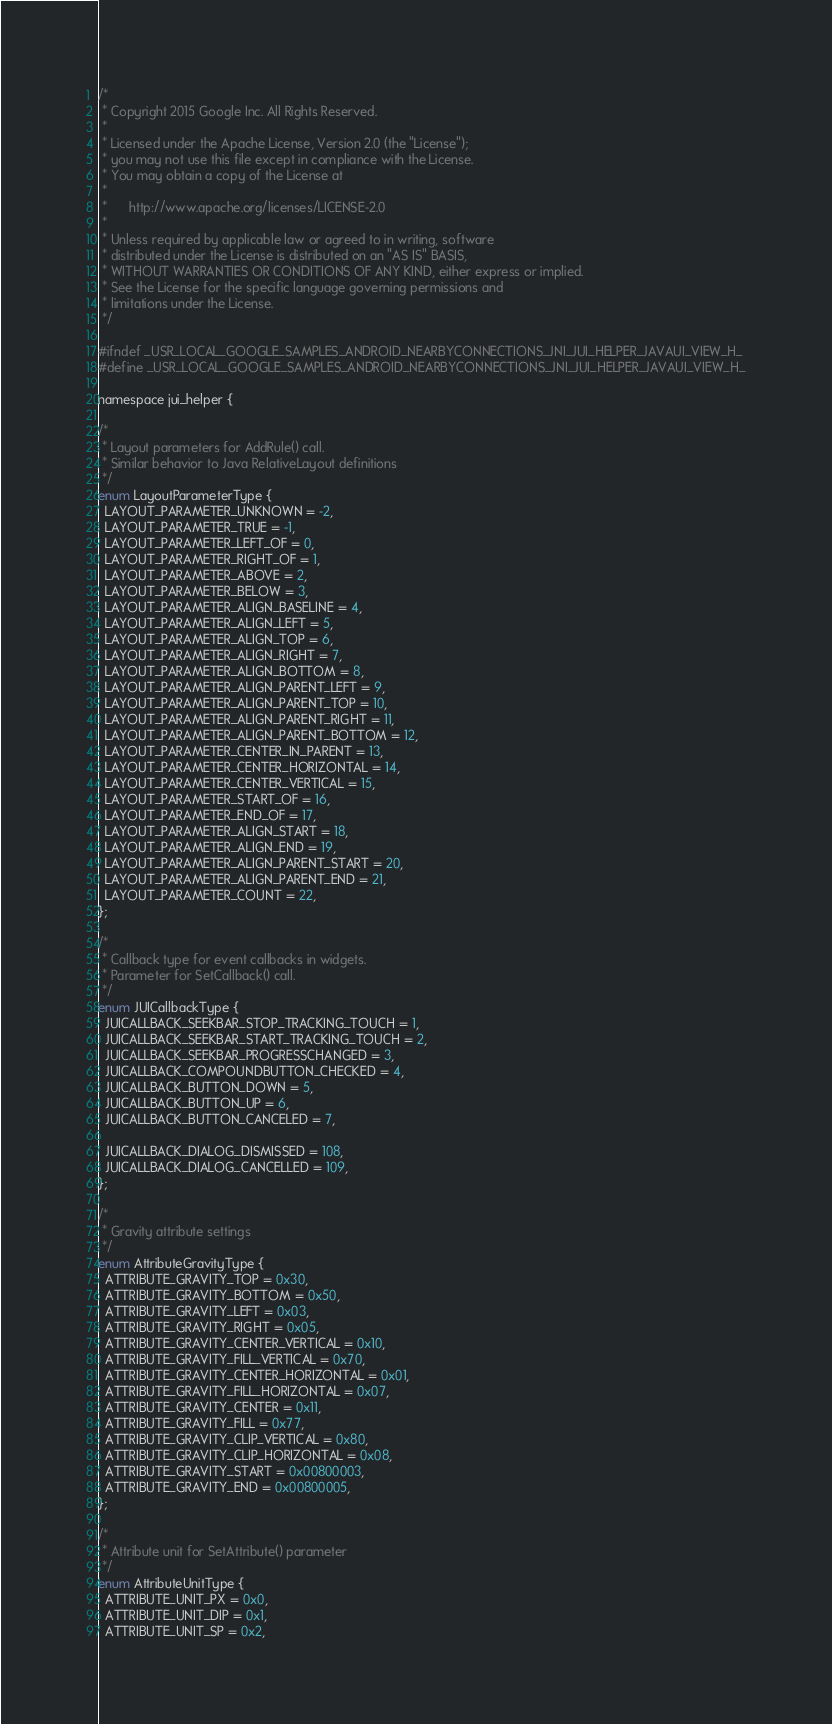Convert code to text. <code><loc_0><loc_0><loc_500><loc_500><_C_>/*
 * Copyright 2015 Google Inc. All Rights Reserved.
 *
 * Licensed under the Apache License, Version 2.0 (the "License");
 * you may not use this file except in compliance with the License.
 * You may obtain a copy of the License at
 *
 *      http://www.apache.org/licenses/LICENSE-2.0
 *
 * Unless required by applicable law or agreed to in writing, software
 * distributed under the License is distributed on an "AS IS" BASIS,
 * WITHOUT WARRANTIES OR CONDITIONS OF ANY KIND, either express or implied.
 * See the License for the specific language governing permissions and
 * limitations under the License.
 */

#ifndef _USR_LOCAL_GOOGLE_SAMPLES_ANDROID_NEARBYCONNECTIONS_JNI_JUI_HELPER_JAVAUI_VIEW_H_
#define _USR_LOCAL_GOOGLE_SAMPLES_ANDROID_NEARBYCONNECTIONS_JNI_JUI_HELPER_JAVAUI_VIEW_H_

namespace jui_helper {

/*
 * Layout parameters for AddRule() call.
 * Similar behavior to Java RelativeLayout definitions
 */
enum LayoutParameterType {
  LAYOUT_PARAMETER_UNKNOWN = -2,
  LAYOUT_PARAMETER_TRUE = -1,
  LAYOUT_PARAMETER_LEFT_OF = 0,
  LAYOUT_PARAMETER_RIGHT_OF = 1,
  LAYOUT_PARAMETER_ABOVE = 2,
  LAYOUT_PARAMETER_BELOW = 3,
  LAYOUT_PARAMETER_ALIGN_BASELINE = 4,
  LAYOUT_PARAMETER_ALIGN_LEFT = 5,
  LAYOUT_PARAMETER_ALIGN_TOP = 6,
  LAYOUT_PARAMETER_ALIGN_RIGHT = 7,
  LAYOUT_PARAMETER_ALIGN_BOTTOM = 8,
  LAYOUT_PARAMETER_ALIGN_PARENT_LEFT = 9,
  LAYOUT_PARAMETER_ALIGN_PARENT_TOP = 10,
  LAYOUT_PARAMETER_ALIGN_PARENT_RIGHT = 11,
  LAYOUT_PARAMETER_ALIGN_PARENT_BOTTOM = 12,
  LAYOUT_PARAMETER_CENTER_IN_PARENT = 13,
  LAYOUT_PARAMETER_CENTER_HORIZONTAL = 14,
  LAYOUT_PARAMETER_CENTER_VERTICAL = 15,
  LAYOUT_PARAMETER_START_OF = 16,
  LAYOUT_PARAMETER_END_OF = 17,
  LAYOUT_PARAMETER_ALIGN_START = 18,
  LAYOUT_PARAMETER_ALIGN_END = 19,
  LAYOUT_PARAMETER_ALIGN_PARENT_START = 20,
  LAYOUT_PARAMETER_ALIGN_PARENT_END = 21,
  LAYOUT_PARAMETER_COUNT = 22,
};

/*
 * Callback type for event callbacks in widgets.
 * Parameter for SetCallback() call.
 */
enum JUICallbackType {
  JUICALLBACK_SEEKBAR_STOP_TRACKING_TOUCH = 1,
  JUICALLBACK_SEEKBAR_START_TRACKING_TOUCH = 2,
  JUICALLBACK_SEEKBAR_PROGRESSCHANGED = 3,
  JUICALLBACK_COMPOUNDBUTTON_CHECKED = 4,
  JUICALLBACK_BUTTON_DOWN = 5,
  JUICALLBACK_BUTTON_UP = 6,
  JUICALLBACK_BUTTON_CANCELED = 7,

  JUICALLBACK_DIALOG_DISMISSED = 108,
  JUICALLBACK_DIALOG_CANCELLED = 109,
};

/*
 * Gravity attribute settings
 */
enum AttributeGravityType {
  ATTRIBUTE_GRAVITY_TOP = 0x30,
  ATTRIBUTE_GRAVITY_BOTTOM = 0x50,
  ATTRIBUTE_GRAVITY_LEFT = 0x03,
  ATTRIBUTE_GRAVITY_RIGHT = 0x05,
  ATTRIBUTE_GRAVITY_CENTER_VERTICAL = 0x10,
  ATTRIBUTE_GRAVITY_FILL_VERTICAL = 0x70,
  ATTRIBUTE_GRAVITY_CENTER_HORIZONTAL = 0x01,
  ATTRIBUTE_GRAVITY_FILL_HORIZONTAL = 0x07,
  ATTRIBUTE_GRAVITY_CENTER = 0x11,
  ATTRIBUTE_GRAVITY_FILL = 0x77,
  ATTRIBUTE_GRAVITY_CLIP_VERTICAL = 0x80,
  ATTRIBUTE_GRAVITY_CLIP_HORIZONTAL = 0x08,
  ATTRIBUTE_GRAVITY_START = 0x00800003,
  ATTRIBUTE_GRAVITY_END = 0x00800005,
};

/*
 * Attribute unit for SetAttribute() parameter
 */
enum AttributeUnitType {
  ATTRIBUTE_UNIT_PX = 0x0,
  ATTRIBUTE_UNIT_DIP = 0x1,
  ATTRIBUTE_UNIT_SP = 0x2,</code> 